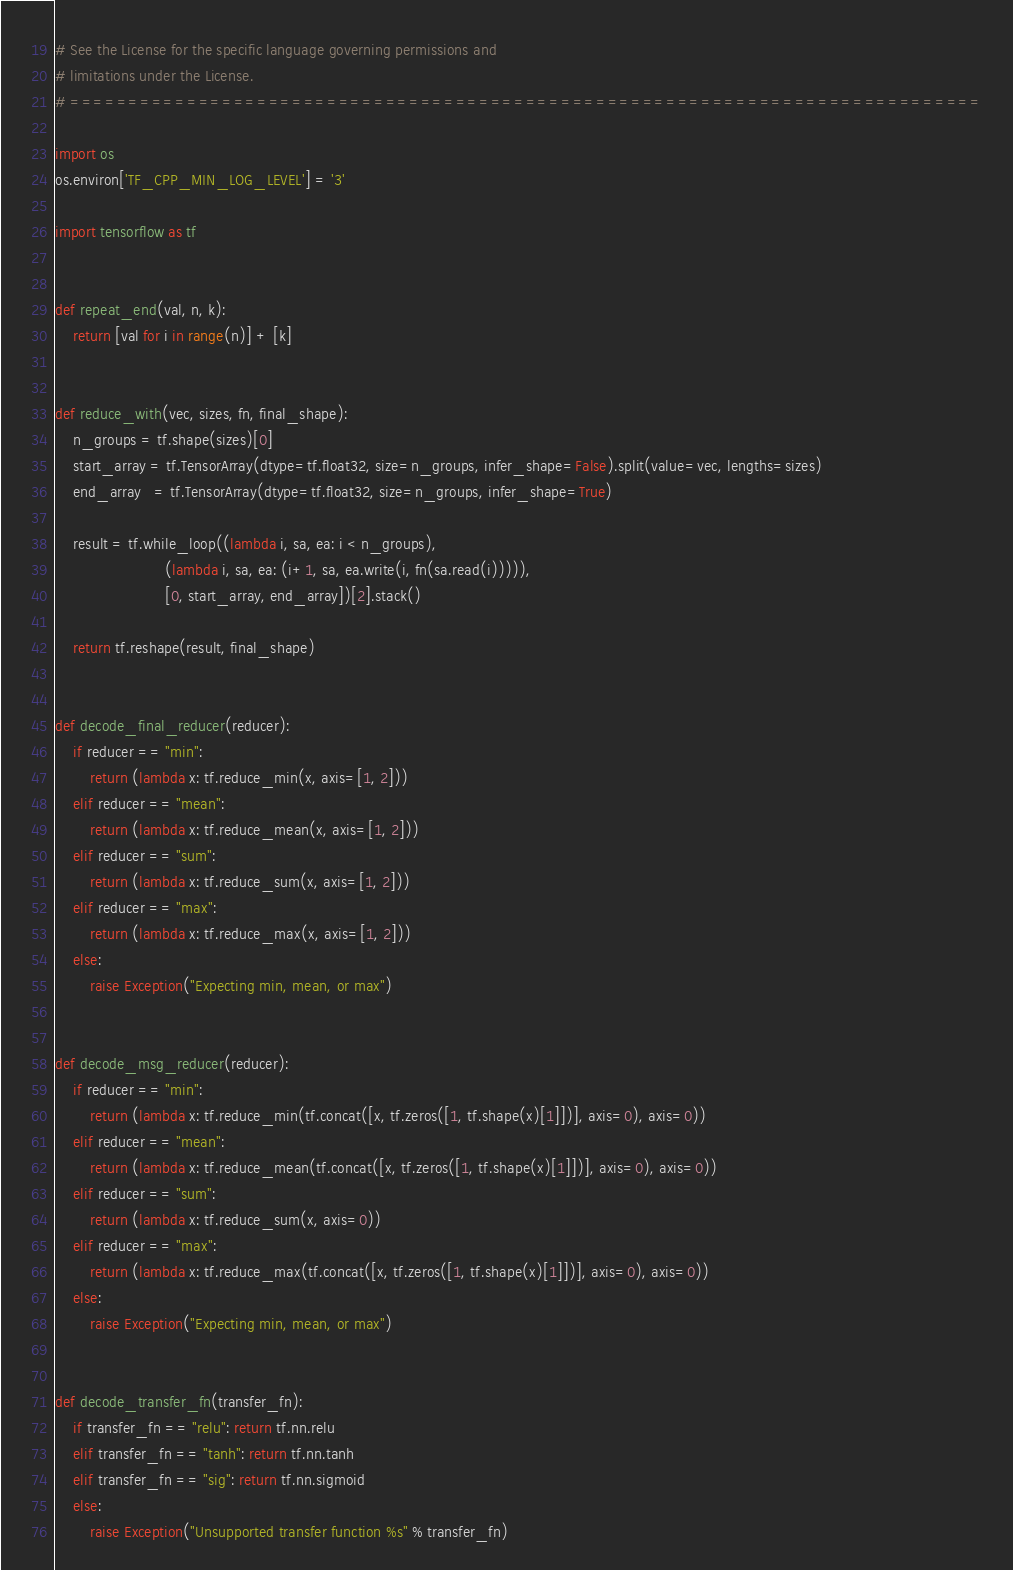Convert code to text. <code><loc_0><loc_0><loc_500><loc_500><_Python_># See the License for the specific language governing permissions and
# limitations under the License.
# ==============================================================================

import os
os.environ['TF_CPP_MIN_LOG_LEVEL'] = '3'

import tensorflow as tf


def repeat_end(val, n, k):
    return [val for i in range(n)] + [k]


def reduce_with(vec, sizes, fn, final_shape):
    n_groups = tf.shape(sizes)[0]
    start_array = tf.TensorArray(dtype=tf.float32, size=n_groups, infer_shape=False).split(value=vec, lengths=sizes)
    end_array   = tf.TensorArray(dtype=tf.float32, size=n_groups, infer_shape=True)

    result = tf.while_loop((lambda i, sa, ea: i < n_groups),
                         (lambda i, sa, ea: (i+1, sa, ea.write(i, fn(sa.read(i))))),
                         [0, start_array, end_array])[2].stack()

    return tf.reshape(result, final_shape)


def decode_final_reducer(reducer):
    if reducer == "min":
        return (lambda x: tf.reduce_min(x, axis=[1, 2]))
    elif reducer == "mean":
        return (lambda x: tf.reduce_mean(x, axis=[1, 2]))
    elif reducer == "sum":
        return (lambda x: tf.reduce_sum(x, axis=[1, 2]))
    elif reducer == "max":
        return (lambda x: tf.reduce_max(x, axis=[1, 2]))
    else:
        raise Exception("Expecting min, mean, or max")


def decode_msg_reducer(reducer):
    if reducer == "min":
        return (lambda x: tf.reduce_min(tf.concat([x, tf.zeros([1, tf.shape(x)[1]])], axis=0), axis=0))
    elif reducer == "mean":
        return (lambda x: tf.reduce_mean(tf.concat([x, tf.zeros([1, tf.shape(x)[1]])], axis=0), axis=0))
    elif reducer == "sum":
        return (lambda x: tf.reduce_sum(x, axis=0))
    elif reducer == "max":
        return (lambda x: tf.reduce_max(tf.concat([x, tf.zeros([1, tf.shape(x)[1]])], axis=0), axis=0))
    else:
        raise Exception("Expecting min, mean, or max")


def decode_transfer_fn(transfer_fn):
    if transfer_fn == "relu": return tf.nn.relu
    elif transfer_fn == "tanh": return tf.nn.tanh
    elif transfer_fn == "sig": return tf.nn.sigmoid
    else:
        raise Exception("Unsupported transfer function %s" % transfer_fn)
</code> 